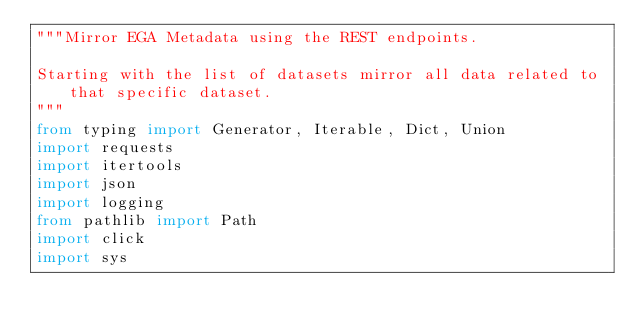Convert code to text. <code><loc_0><loc_0><loc_500><loc_500><_Python_>"""Mirror EGA Metadata using the REST endpoints.

Starting with the list of datasets mirror all data related to that specific dataset.
"""
from typing import Generator, Iterable, Dict, Union
import requests
import itertools
import json
import logging
from pathlib import Path
import click
import sys
</code> 